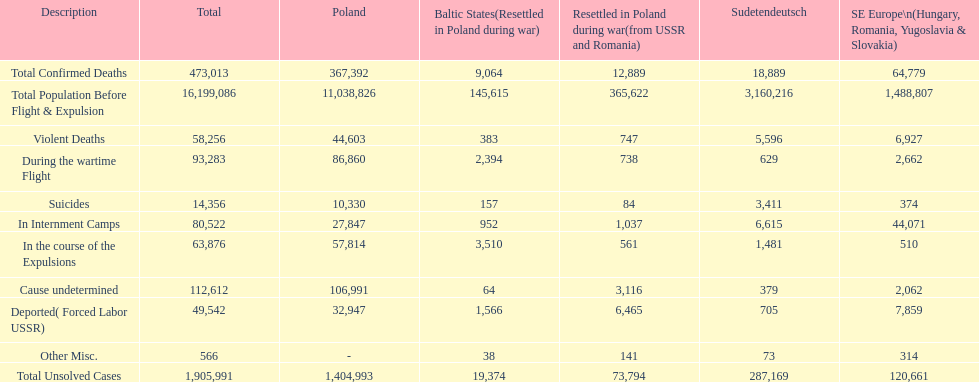What is the total number of violent deaths across all regions? 58,256. 